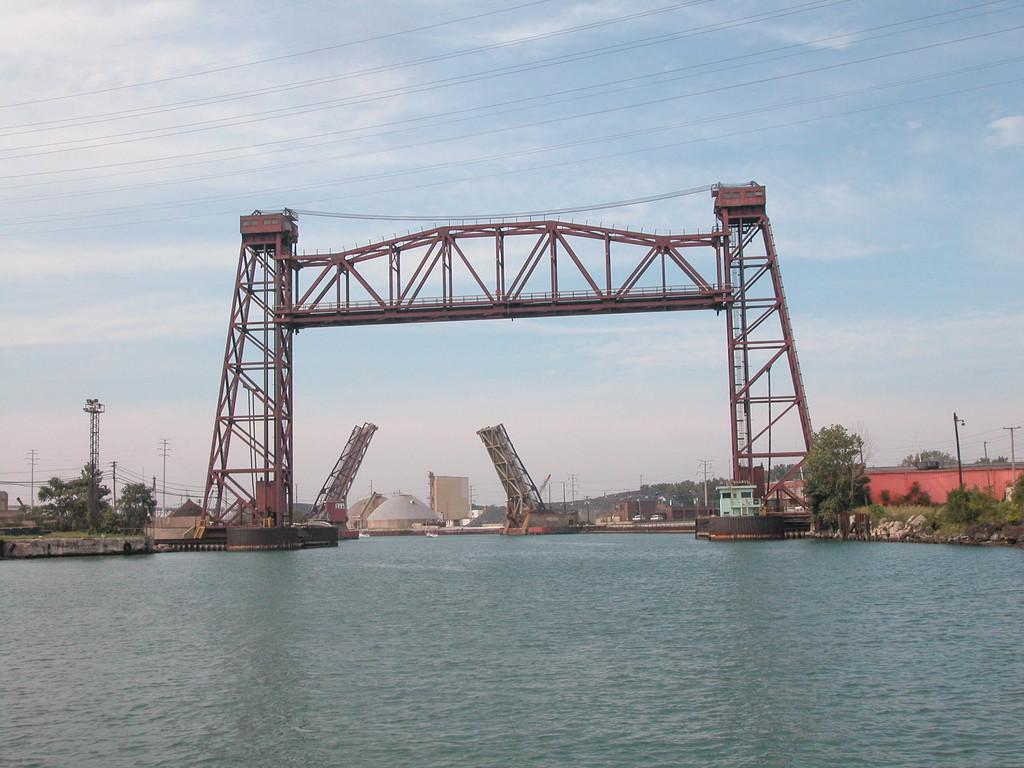What type of structure can be seen in the image? There is a bridge in the image. What else is present in the image besides the bridge? Electric wires, electric poles, trees, buildings, stones, and water are visible in the image. What is the color of the sky in the image? The sky is cloudy and pale blue in the image. Where is the wren perched in the image? There is no wren present in the image. What type of cable is being used to transmit electricity in the image? The image does not provide information about the type of cable used for transmitting electricity. 